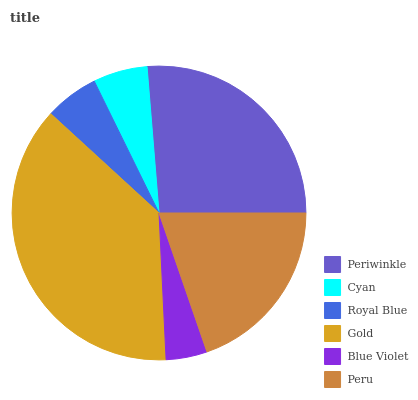Is Blue Violet the minimum?
Answer yes or no. Yes. Is Gold the maximum?
Answer yes or no. Yes. Is Cyan the minimum?
Answer yes or no. No. Is Cyan the maximum?
Answer yes or no. No. Is Periwinkle greater than Cyan?
Answer yes or no. Yes. Is Cyan less than Periwinkle?
Answer yes or no. Yes. Is Cyan greater than Periwinkle?
Answer yes or no. No. Is Periwinkle less than Cyan?
Answer yes or no. No. Is Peru the high median?
Answer yes or no. Yes. Is Cyan the low median?
Answer yes or no. Yes. Is Gold the high median?
Answer yes or no. No. Is Periwinkle the low median?
Answer yes or no. No. 